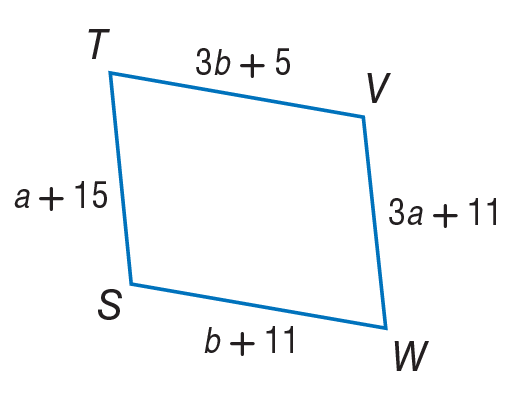Answer the mathemtical geometry problem and directly provide the correct option letter.
Question: Use parallelogram to, find a.
Choices: A: 1 B: 2 C: 3 D: 4 B 